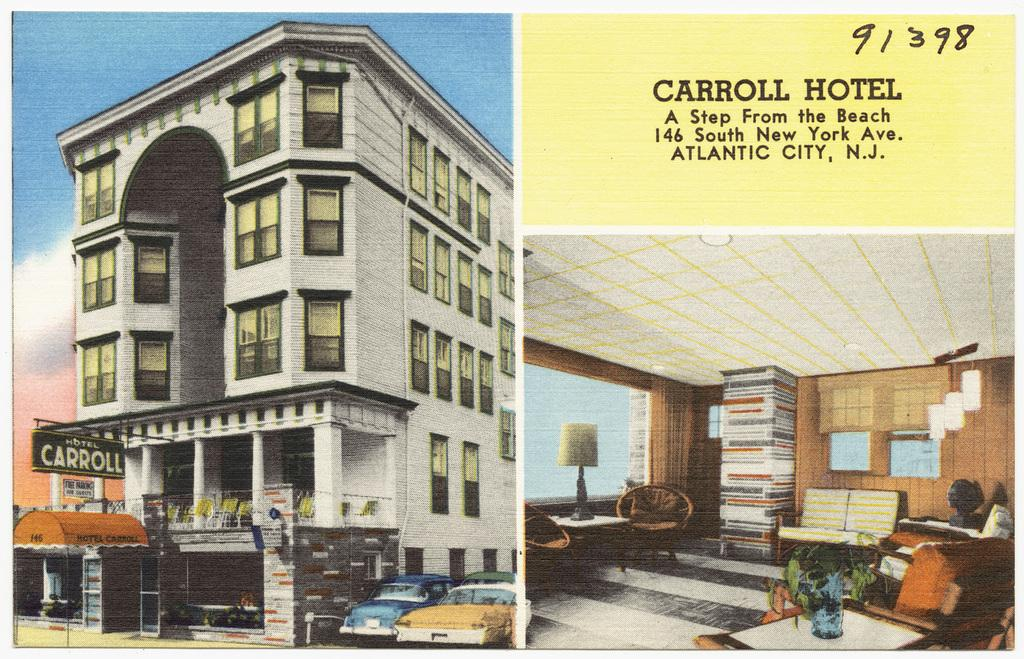<image>
Relay a brief, clear account of the picture shown. Carroll Hotel of Atlantic City is shown on this advert. 